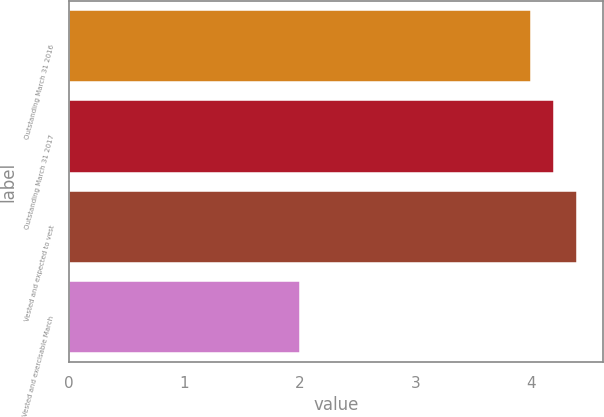<chart> <loc_0><loc_0><loc_500><loc_500><bar_chart><fcel>Outstanding March 31 2016<fcel>Outstanding March 31 2017<fcel>Vested and expected to vest<fcel>Vested and exercisable March<nl><fcel>4<fcel>4.2<fcel>4.4<fcel>2<nl></chart> 